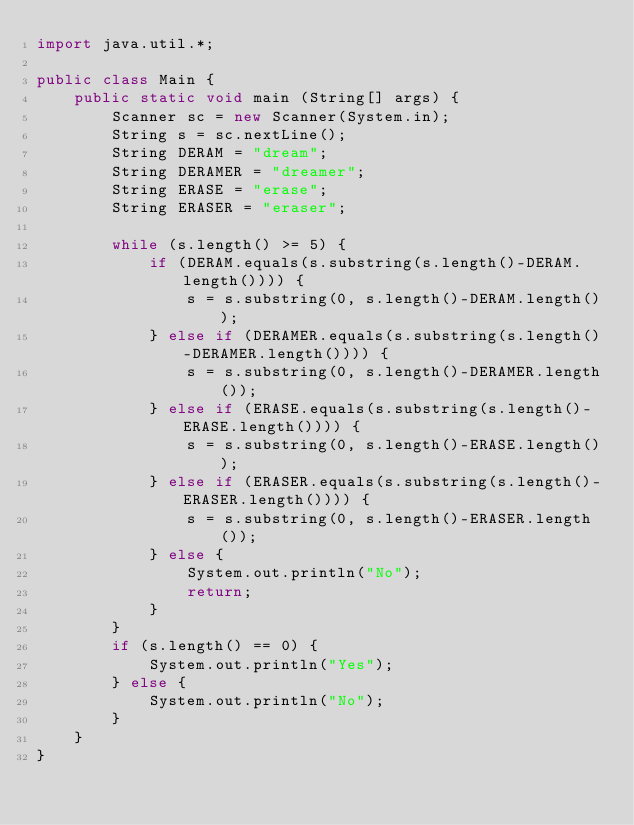<code> <loc_0><loc_0><loc_500><loc_500><_Java_>import java.util.*;

public class Main {
    public static void main (String[] args) {
        Scanner sc = new Scanner(System.in);
        String s = sc.nextLine();
        String DERAM = "dream";
        String DERAMER = "dreamer";
        String ERASE = "erase";
        String ERASER = "eraser";

        while (s.length() >= 5) {
            if (DERAM.equals(s.substring(s.length()-DERAM.length()))) {
                s = s.substring(0, s.length()-DERAM.length());
            } else if (DERAMER.equals(s.substring(s.length()-DERAMER.length()))) {
                s = s.substring(0, s.length()-DERAMER.length());
            } else if (ERASE.equals(s.substring(s.length()-ERASE.length()))) {
                s = s.substring(0, s.length()-ERASE.length());
            } else if (ERASER.equals(s.substring(s.length()-ERASER.length()))) {
                s = s.substring(0, s.length()-ERASER.length());
            } else {
                System.out.println("No");
                return;
            }
        }
        if (s.length() == 0) {
            System.out.println("Yes");
        } else {
            System.out.println("No");
        }
    }
}</code> 